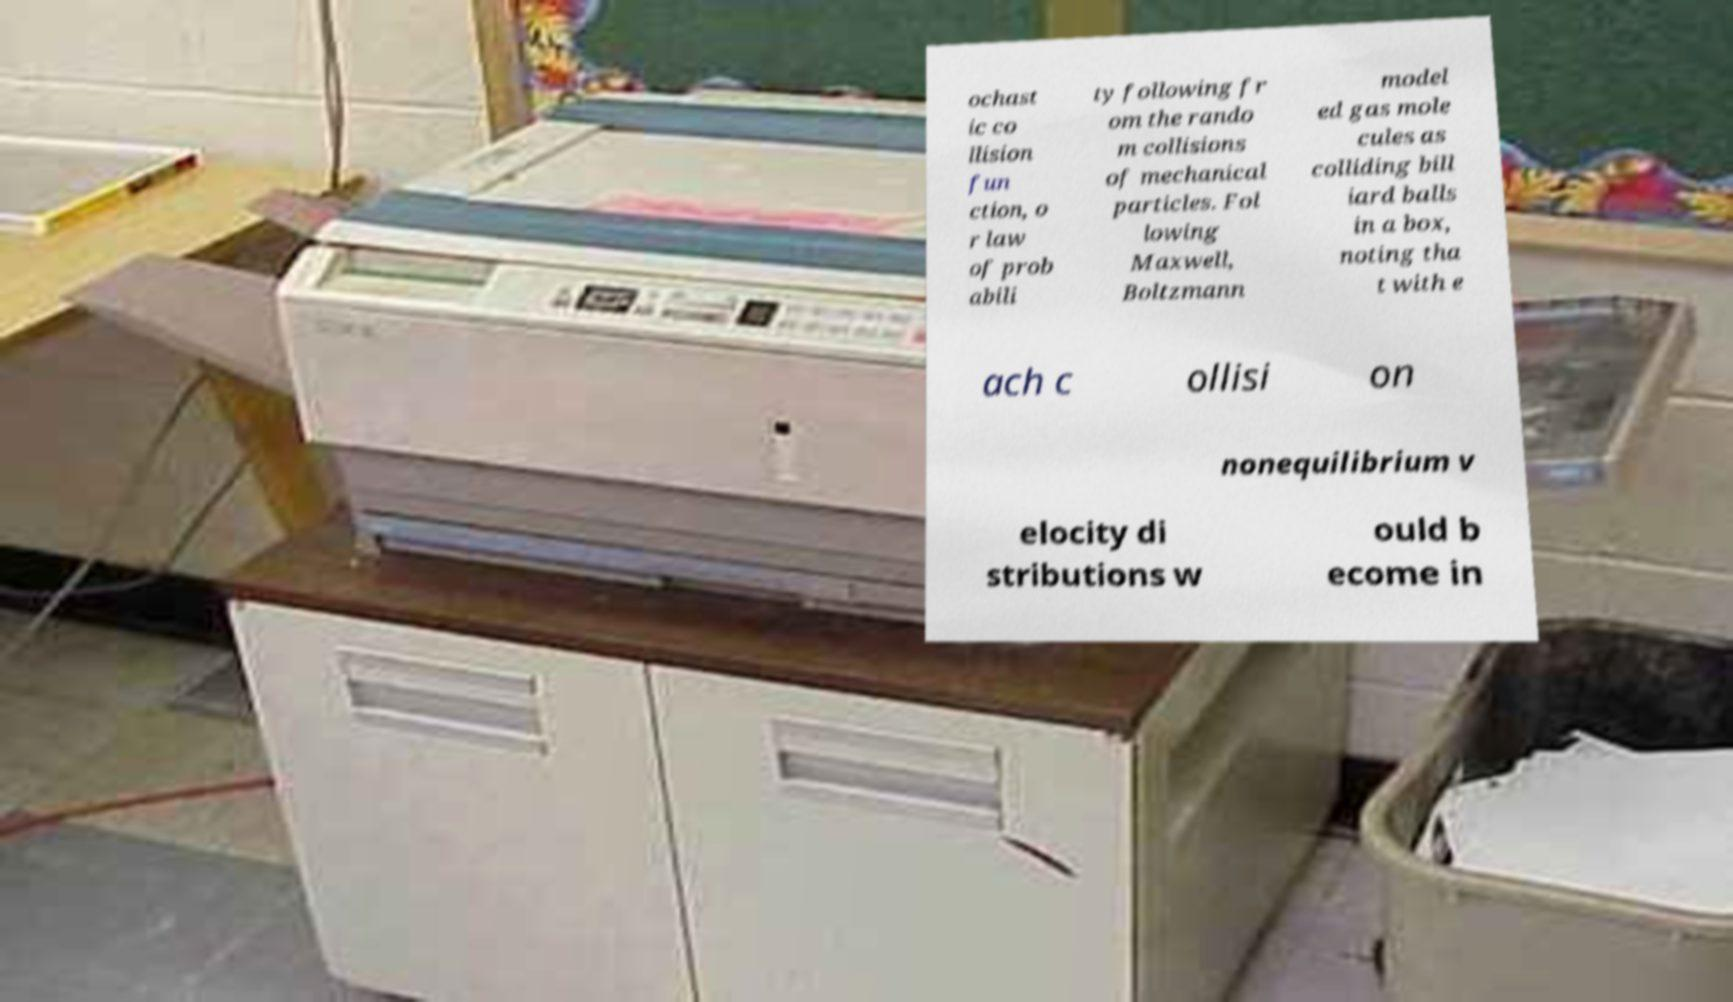What messages or text are displayed in this image? I need them in a readable, typed format. ochast ic co llision fun ction, o r law of prob abili ty following fr om the rando m collisions of mechanical particles. Fol lowing Maxwell, Boltzmann model ed gas mole cules as colliding bill iard balls in a box, noting tha t with e ach c ollisi on nonequilibrium v elocity di stributions w ould b ecome in 